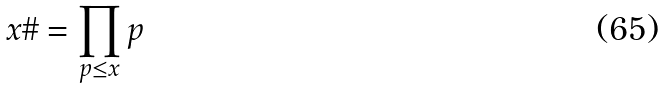Convert formula to latex. <formula><loc_0><loc_0><loc_500><loc_500>x \# = \prod _ { p \leq x } p</formula> 